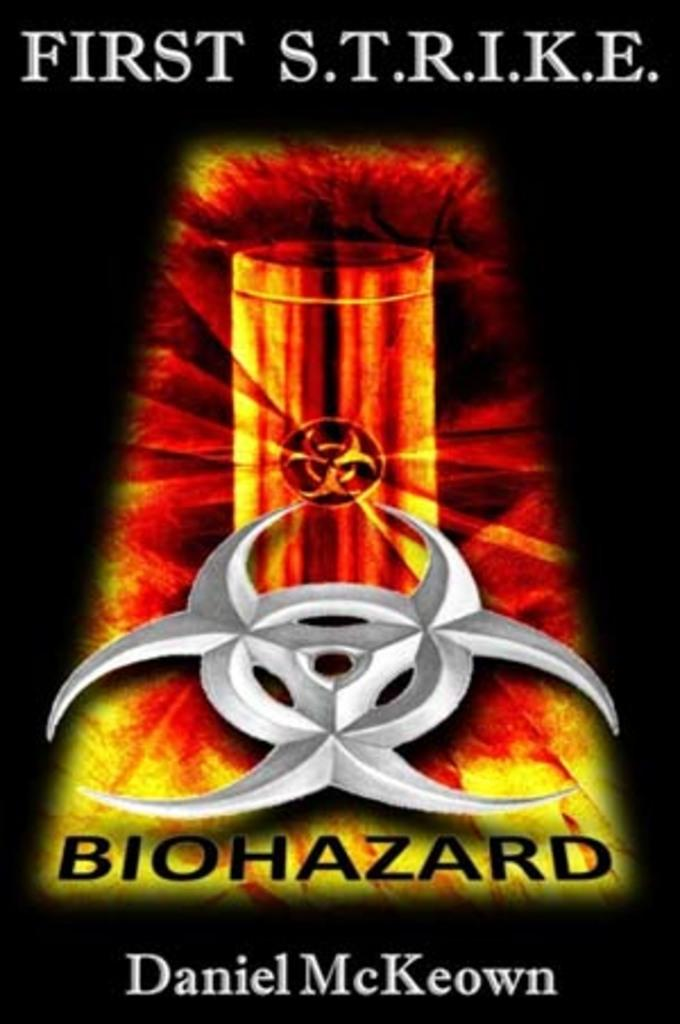<image>
Offer a succinct explanation of the picture presented. a book cover for First Strike biohazard by Daniel McKeown 